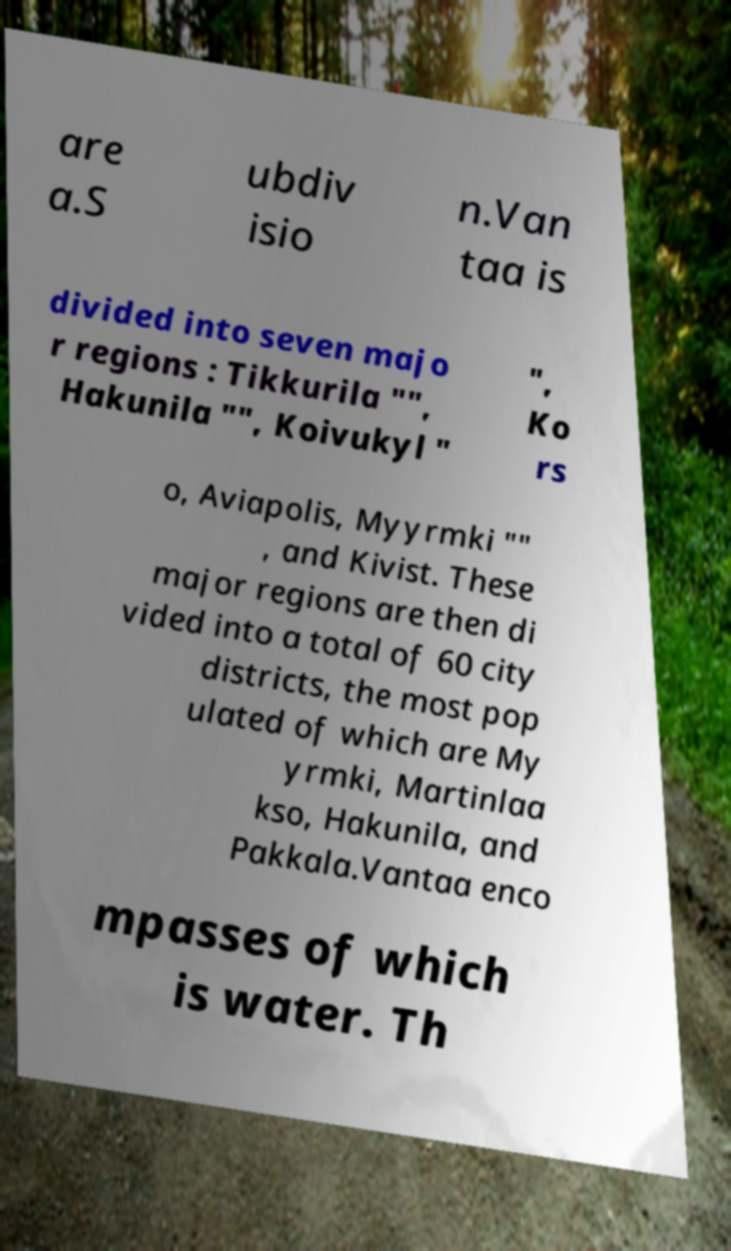For documentation purposes, I need the text within this image transcribed. Could you provide that? are a.S ubdiv isio n.Van taa is divided into seven majo r regions : Tikkurila "", Hakunila "", Koivukyl " ", Ko rs o, Aviapolis, Myyrmki "" , and Kivist. These major regions are then di vided into a total of 60 city districts, the most pop ulated of which are My yrmki, Martinlaa kso, Hakunila, and Pakkala.Vantaa enco mpasses of which is water. Th 